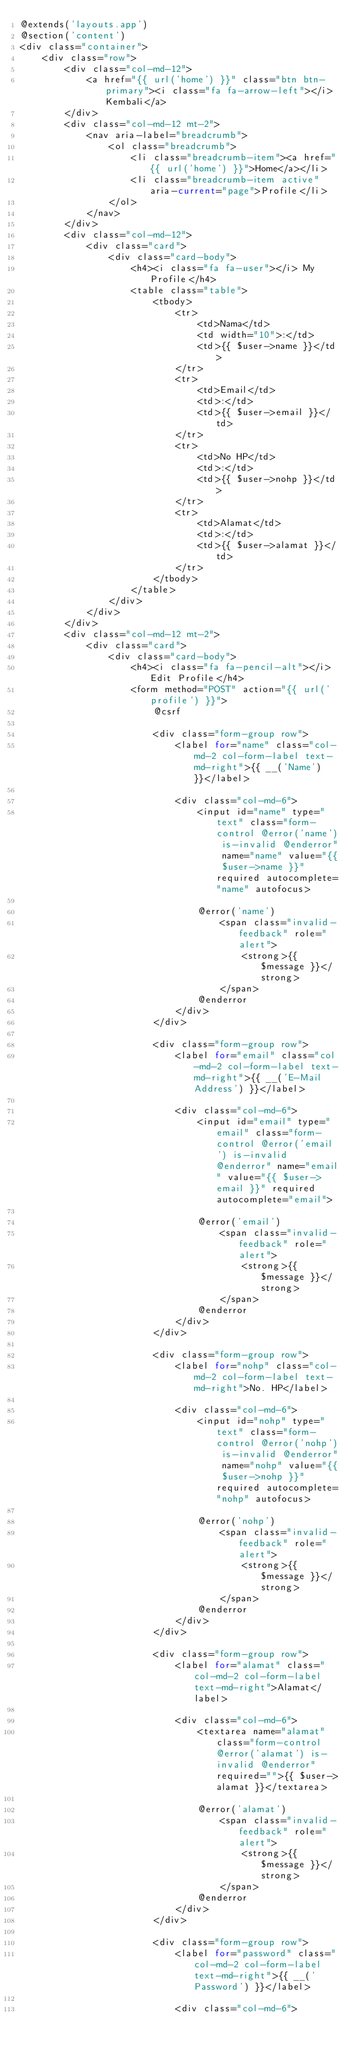Convert code to text. <code><loc_0><loc_0><loc_500><loc_500><_PHP_>@extends('layouts.app')
@section('content')
<div class="container">
    <div class="row">
        <div class="col-md-12">
            <a href="{{ url('home') }}" class="btn btn-primary"><i class="fa fa-arrow-left"></i> Kembali</a>
        </div>
        <div class="col-md-12 mt-2">
            <nav aria-label="breadcrumb">
                <ol class="breadcrumb">
                    <li class="breadcrumb-item"><a href="{{ url('home') }}">Home</a></li>
                    <li class="breadcrumb-item active" aria-current="page">Profile</li>
                </ol>
            </nav>
        </div>
        <div class="col-md-12">
            <div class="card">
                <div class="card-body">
                    <h4><i class="fa fa-user"></i> My Profile</h4>
                    <table class="table">
                        <tbody>
                            <tr>
                                <td>Nama</td>
                                <td width="10">:</td>
                                <td>{{ $user->name }}</td>
                            </tr>
                            <tr>
                                <td>Email</td>
                                <td>:</td>
                                <td>{{ $user->email }}</td>
                            </tr>
                            <tr>
                                <td>No HP</td>
                                <td>:</td>
                                <td>{{ $user->nohp }}</td>
                            </tr>
                            <tr>
                                <td>Alamat</td>
                                <td>:</td>
                                <td>{{ $user->alamat }}</td>
                            </tr>
                        </tbody>
                    </table>
                </div>
            </div>
        </div>
        <div class="col-md-12 mt-2">
            <div class="card">
                <div class="card-body">
                    <h4><i class="fa fa-pencil-alt"></i> Edit Profile</h4>
                    <form method="POST" action="{{ url('profile') }}">
                        @csrf

                        <div class="form-group row">
                            <label for="name" class="col-md-2 col-form-label text-md-right">{{ __('Name') }}</label>

                            <div class="col-md-6">
                                <input id="name" type="text" class="form-control @error('name') is-invalid @enderror" name="name" value="{{ $user->name }}" required autocomplete="name" autofocus>

                                @error('name')
                                    <span class="invalid-feedback" role="alert">
                                        <strong>{{ $message }}</strong>
                                    </span>
                                @enderror
                            </div>
                        </div>

                        <div class="form-group row">
                            <label for="email" class="col-md-2 col-form-label text-md-right">{{ __('E-Mail Address') }}</label>

                            <div class="col-md-6">
                                <input id="email" type="email" class="form-control @error('email') is-invalid @enderror" name="email" value="{{ $user->email }}" required autocomplete="email">

                                @error('email')
                                    <span class="invalid-feedback" role="alert">
                                        <strong>{{ $message }}</strong>
                                    </span>
                                @enderror
                            </div>
                        </div>

                        <div class="form-group row">
                            <label for="nohp" class="col-md-2 col-form-label text-md-right">No. HP</label>

                            <div class="col-md-6">
                                <input id="nohp" type="text" class="form-control @error('nohp') is-invalid @enderror" name="nohp" value="{{ $user->nohp }}" required autocomplete="nohp" autofocus>

                                @error('nohp')
                                    <span class="invalid-feedback" role="alert">
                                        <strong>{{ $message }}</strong>
                                    </span>
                                @enderror
                            </div>
                        </div>

                        <div class="form-group row">
                            <label for="alamat" class="col-md-2 col-form-label text-md-right">Alamat</label>

                            <div class="col-md-6">
                                <textarea name="alamat" class="form-control @error('alamat') is-invalid @enderror" required="">{{ $user->alamat }}</textarea>

                                @error('alamat')
                                    <span class="invalid-feedback" role="alert">
                                        <strong>{{ $message }}</strong>
                                    </span>
                                @enderror
                            </div>
                        </div>

                        <div class="form-group row">
                            <label for="password" class="col-md-2 col-form-label text-md-right">{{ __('Password') }}</label>

                            <div class="col-md-6"></code> 